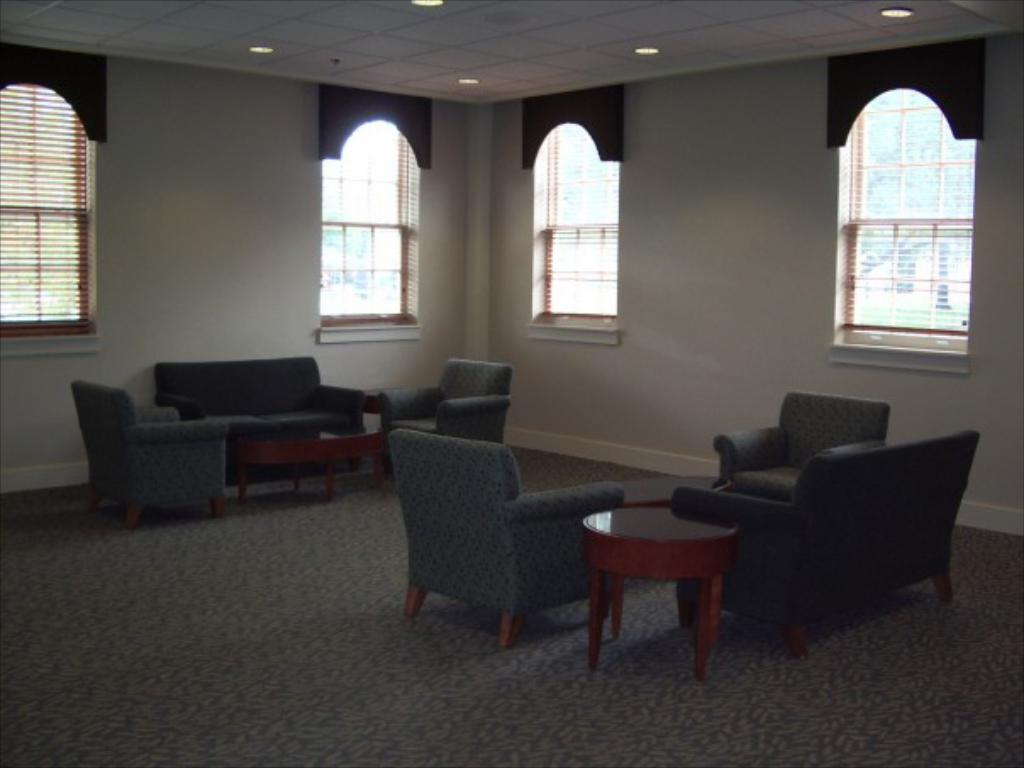What type of furniture is present in the image? There is a sofa set in the image. How many tables can be seen in the image? There are 3 tables in the image. What is visible in the background of the image? There is a wall, windows, and lights on the ceiling in the background of the image. Can you see a river flowing through the room in the image? No, there is no river present in the image. 